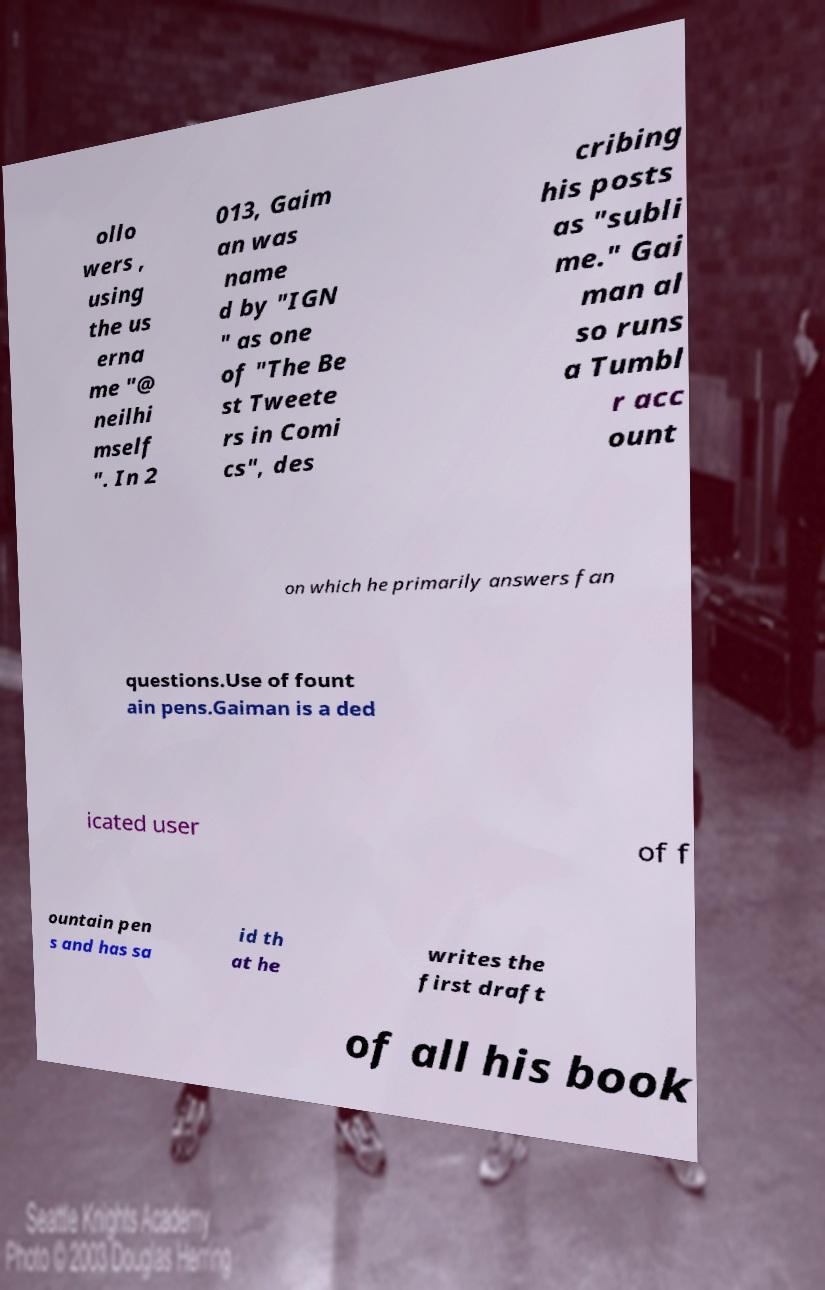I need the written content from this picture converted into text. Can you do that? ollo wers , using the us erna me "@ neilhi mself ". In 2 013, Gaim an was name d by "IGN " as one of "The Be st Tweete rs in Comi cs", des cribing his posts as "subli me." Gai man al so runs a Tumbl r acc ount on which he primarily answers fan questions.Use of fount ain pens.Gaiman is a ded icated user of f ountain pen s and has sa id th at he writes the first draft of all his book 